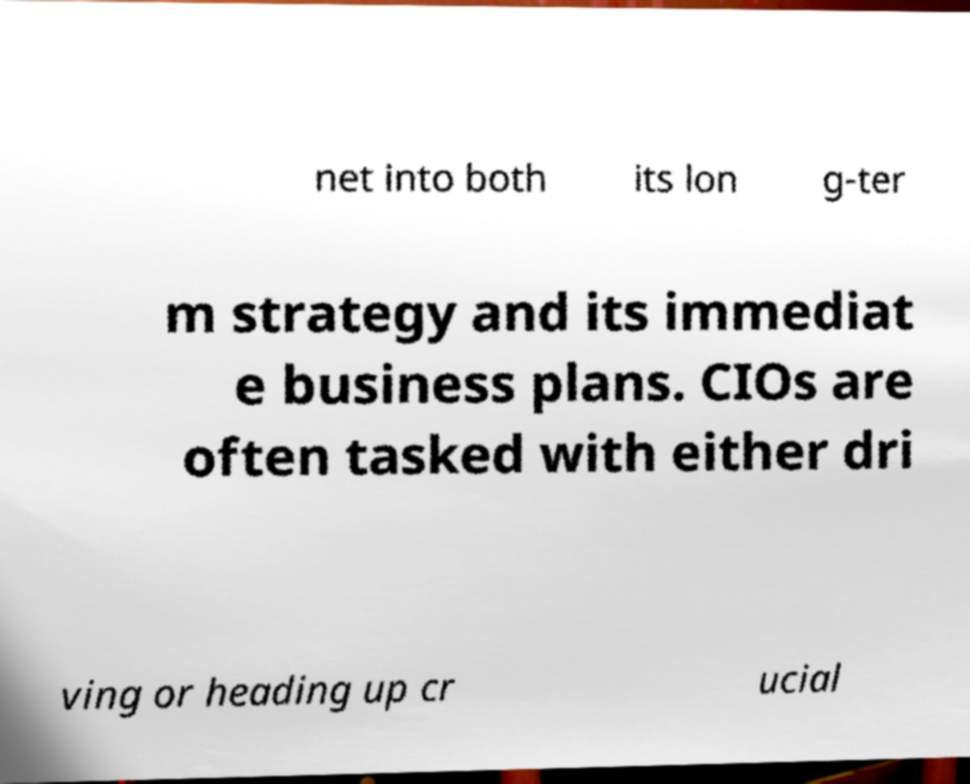For documentation purposes, I need the text within this image transcribed. Could you provide that? net into both its lon g-ter m strategy and its immediat e business plans. CIOs are often tasked with either dri ving or heading up cr ucial 